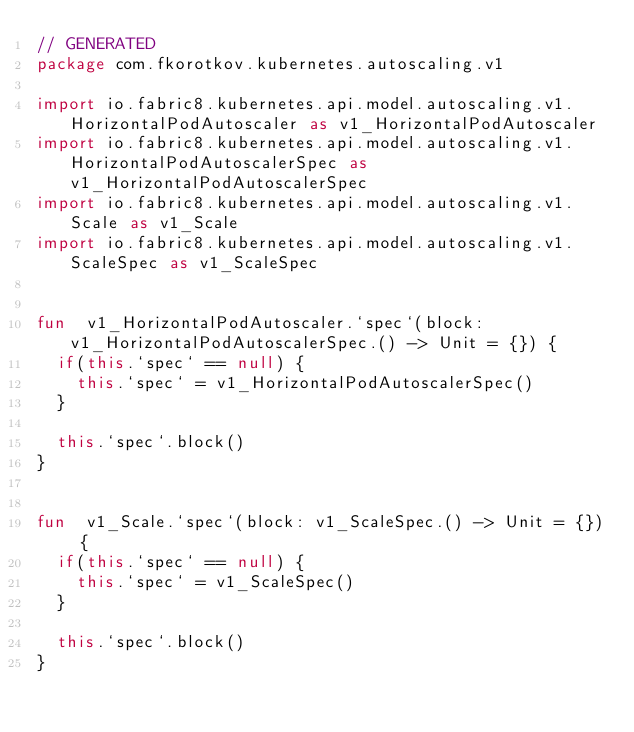Convert code to text. <code><loc_0><loc_0><loc_500><loc_500><_Kotlin_>// GENERATED
package com.fkorotkov.kubernetes.autoscaling.v1

import io.fabric8.kubernetes.api.model.autoscaling.v1.HorizontalPodAutoscaler as v1_HorizontalPodAutoscaler
import io.fabric8.kubernetes.api.model.autoscaling.v1.HorizontalPodAutoscalerSpec as v1_HorizontalPodAutoscalerSpec
import io.fabric8.kubernetes.api.model.autoscaling.v1.Scale as v1_Scale
import io.fabric8.kubernetes.api.model.autoscaling.v1.ScaleSpec as v1_ScaleSpec


fun  v1_HorizontalPodAutoscaler.`spec`(block: v1_HorizontalPodAutoscalerSpec.() -> Unit = {}) {
  if(this.`spec` == null) {
    this.`spec` = v1_HorizontalPodAutoscalerSpec()
  }

  this.`spec`.block()
}


fun  v1_Scale.`spec`(block: v1_ScaleSpec.() -> Unit = {}) {
  if(this.`spec` == null) {
    this.`spec` = v1_ScaleSpec()
  }

  this.`spec`.block()
}

</code> 